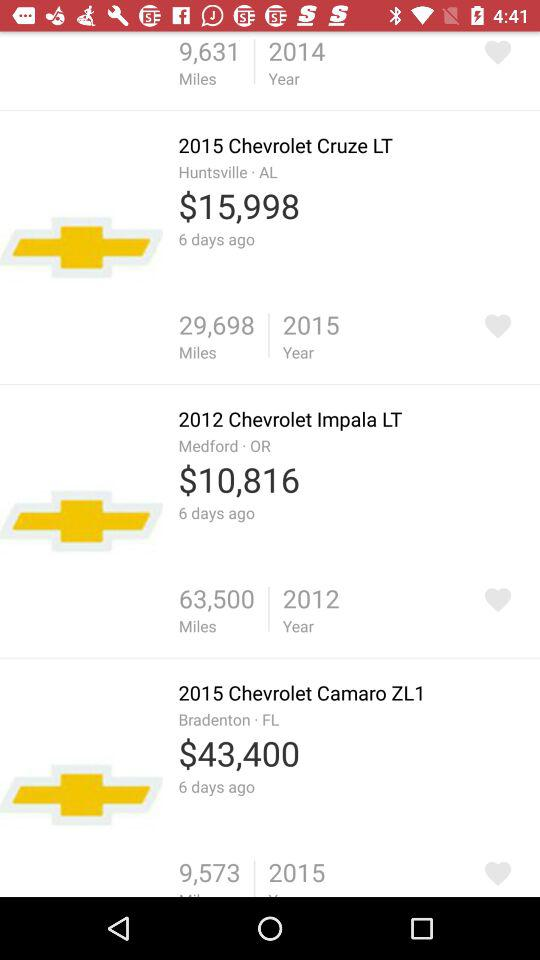What is the price of the "2012 Chevrolet Impala LT"? The price of the "2012 Chevrolet Impala LT" is $10,816. 